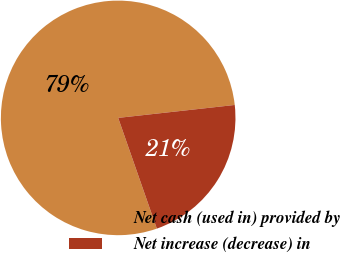Convert chart to OTSL. <chart><loc_0><loc_0><loc_500><loc_500><pie_chart><fcel>Net cash (used in) provided by<fcel>Net increase (decrease) in<nl><fcel>78.59%<fcel>21.41%<nl></chart> 